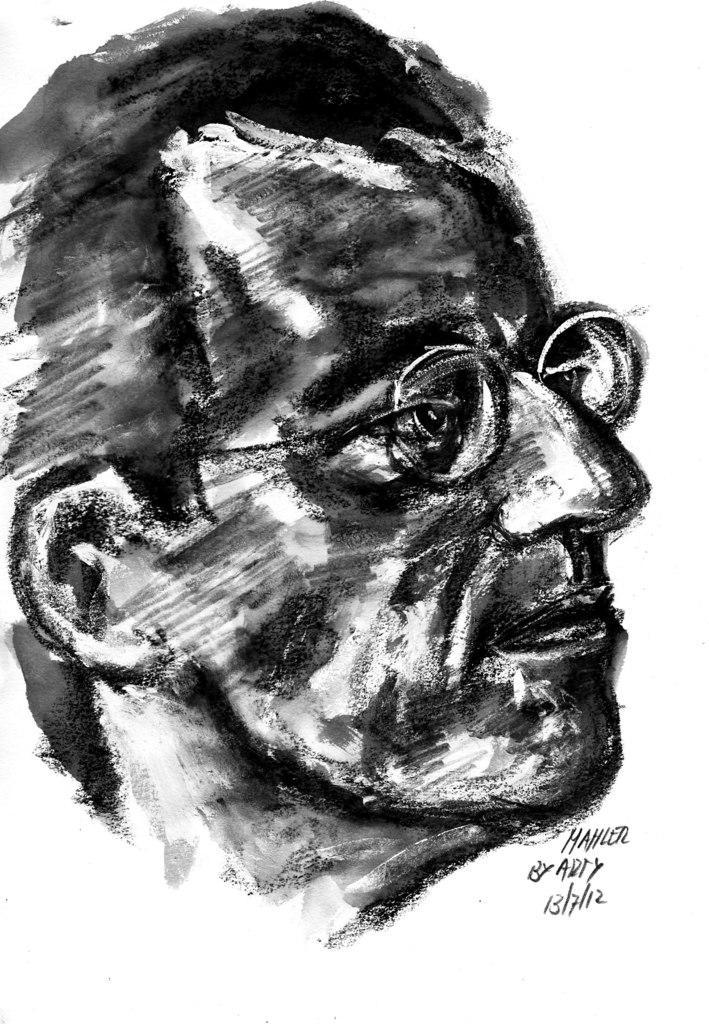How would you summarize this image in a sentence or two? In this image we can see a sketch of a person and some text, the background is white. 